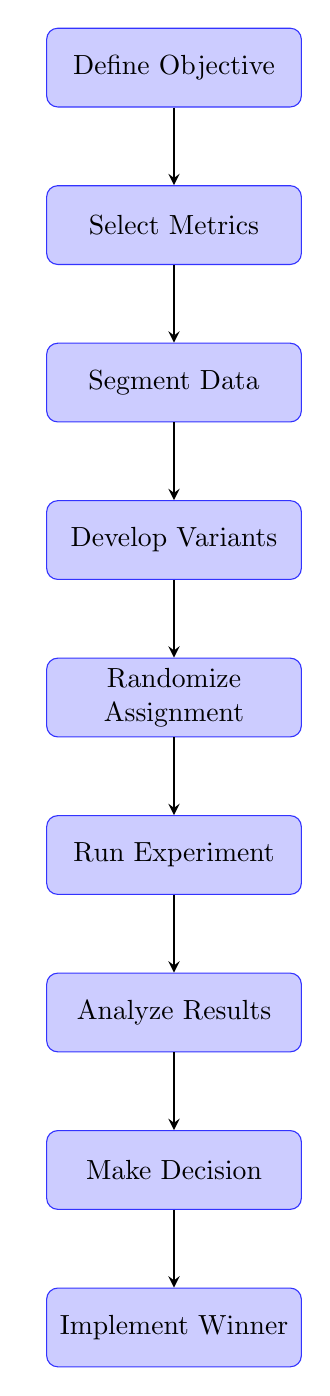What is the first node in the flow? The first node is labeled "Define Objective", indicating it is the starting point of the flowchart.
Answer: Define Objective How many nodes are in the diagram? By counting the listed nodes, there are a total of nine nodes that represent different steps in the A/B testing process.
Answer: 9 What follows "Analyze Results"? The node directly following "Analyze Results" is "Make Decision", which indicates the next step after analyzing the results of the A/B test.
Answer: Make Decision What is the last step in the flow? The last step in the flowchart is "Implement Winner", which represents the action taken after deciding which model to adopt.
Answer: Implement Winner Which node connects to "Randomize Assignment"? The node that connects to "Randomize Assignment" is "Develop Variants", showing that models need to be created before random assignment occurs.
Answer: Develop Variants What metric is typically selected before segmenting data? The metric chosen before segmenting the data is part of the "Select Metrics" step, which is crucial for measuring the performance in the A/B test.
Answer: Select Metrics Which two nodes indicate decision-making in the flow? The nodes indicating decision-making are "Make Decision" and "Analyze Results", as they both involve evaluating information to guide subsequent actions.
Answer: Make Decision, Analyze Results What is necessary before running the experiment? Before the experiment can be run, "Randomize Assignment" must be completed to ensure that data points are assigned without bias.
Answer: Randomize Assignment What is the relationship between "Segment Data" and "Develop Variants"? The relationship is sequential; "Segment Data" comes before "Develop Variants", indicating that data must be split into groups before creating the model variants.
Answer: Sequential relationship 